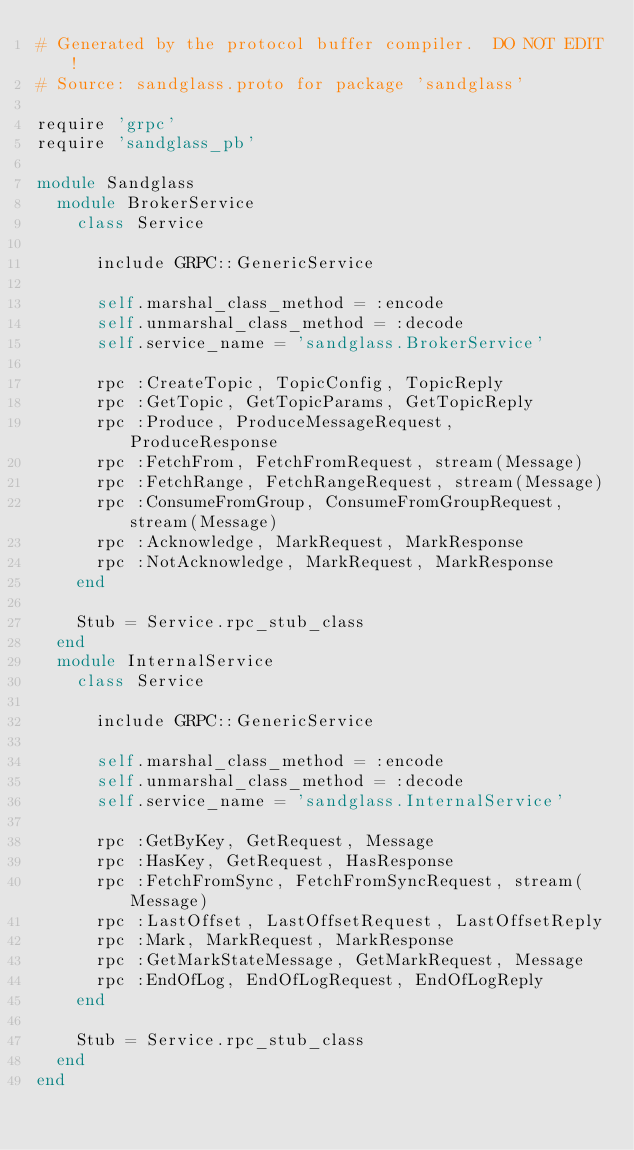Convert code to text. <code><loc_0><loc_0><loc_500><loc_500><_Ruby_># Generated by the protocol buffer compiler.  DO NOT EDIT!
# Source: sandglass.proto for package 'sandglass'

require 'grpc'
require 'sandglass_pb'

module Sandglass
  module BrokerService
    class Service

      include GRPC::GenericService

      self.marshal_class_method = :encode
      self.unmarshal_class_method = :decode
      self.service_name = 'sandglass.BrokerService'

      rpc :CreateTopic, TopicConfig, TopicReply
      rpc :GetTopic, GetTopicParams, GetTopicReply
      rpc :Produce, ProduceMessageRequest, ProduceResponse
      rpc :FetchFrom, FetchFromRequest, stream(Message)
      rpc :FetchRange, FetchRangeRequest, stream(Message)
      rpc :ConsumeFromGroup, ConsumeFromGroupRequest, stream(Message)
      rpc :Acknowledge, MarkRequest, MarkResponse
      rpc :NotAcknowledge, MarkRequest, MarkResponse
    end

    Stub = Service.rpc_stub_class
  end
  module InternalService
    class Service

      include GRPC::GenericService

      self.marshal_class_method = :encode
      self.unmarshal_class_method = :decode
      self.service_name = 'sandglass.InternalService'

      rpc :GetByKey, GetRequest, Message
      rpc :HasKey, GetRequest, HasResponse
      rpc :FetchFromSync, FetchFromSyncRequest, stream(Message)
      rpc :LastOffset, LastOffsetRequest, LastOffsetReply
      rpc :Mark, MarkRequest, MarkResponse
      rpc :GetMarkStateMessage, GetMarkRequest, Message
      rpc :EndOfLog, EndOfLogRequest, EndOfLogReply
    end

    Stub = Service.rpc_stub_class
  end
end
</code> 